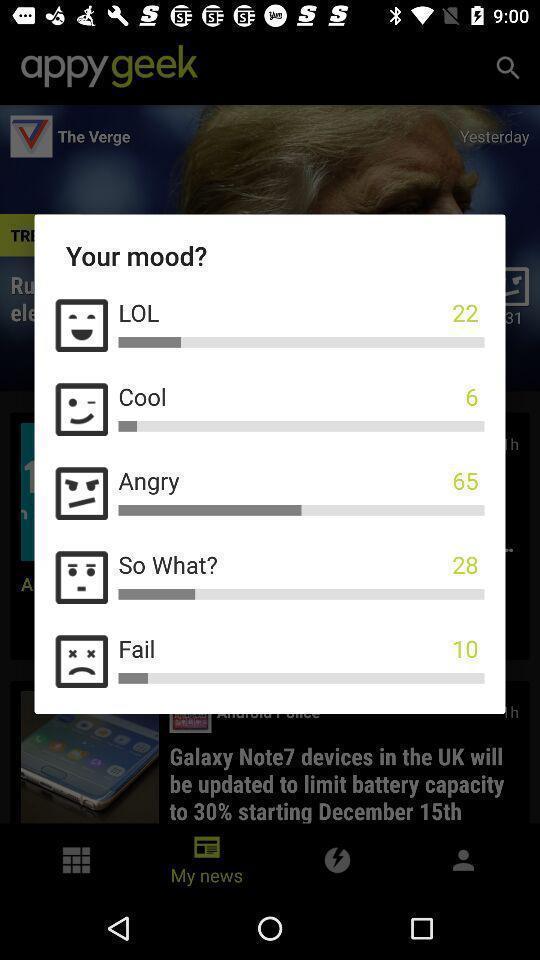Summarize the main components in this picture. Pop-up window showing different mood reactions with emojis. 